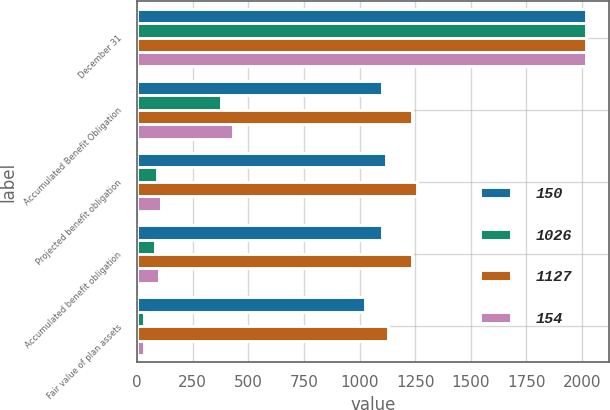Convert chart to OTSL. <chart><loc_0><loc_0><loc_500><loc_500><stacked_bar_chart><ecel><fcel>December 31<fcel>Accumulated Benefit Obligation<fcel>Projected benefit obligation<fcel>Accumulated benefit obligation<fcel>Fair value of plan assets<nl><fcel>150<fcel>2018<fcel>1101<fcel>1118<fcel>1101<fcel>1026<nl><fcel>1026<fcel>2018<fcel>376<fcel>89<fcel>79<fcel>33<nl><fcel>1127<fcel>2017<fcel>1236<fcel>1257<fcel>1236<fcel>1127<nl><fcel>154<fcel>2017<fcel>433<fcel>109<fcel>97<fcel>33<nl></chart> 